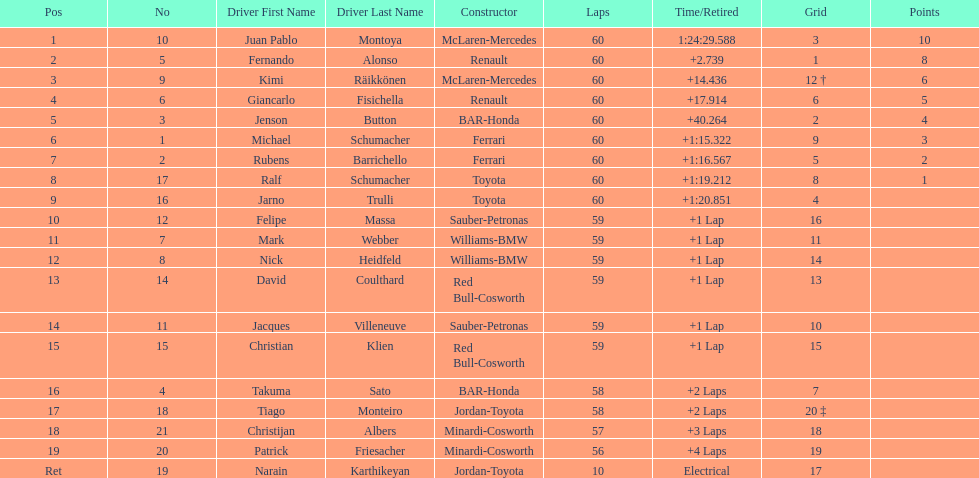Which driver came after giancarlo fisichella? Jenson Button. 